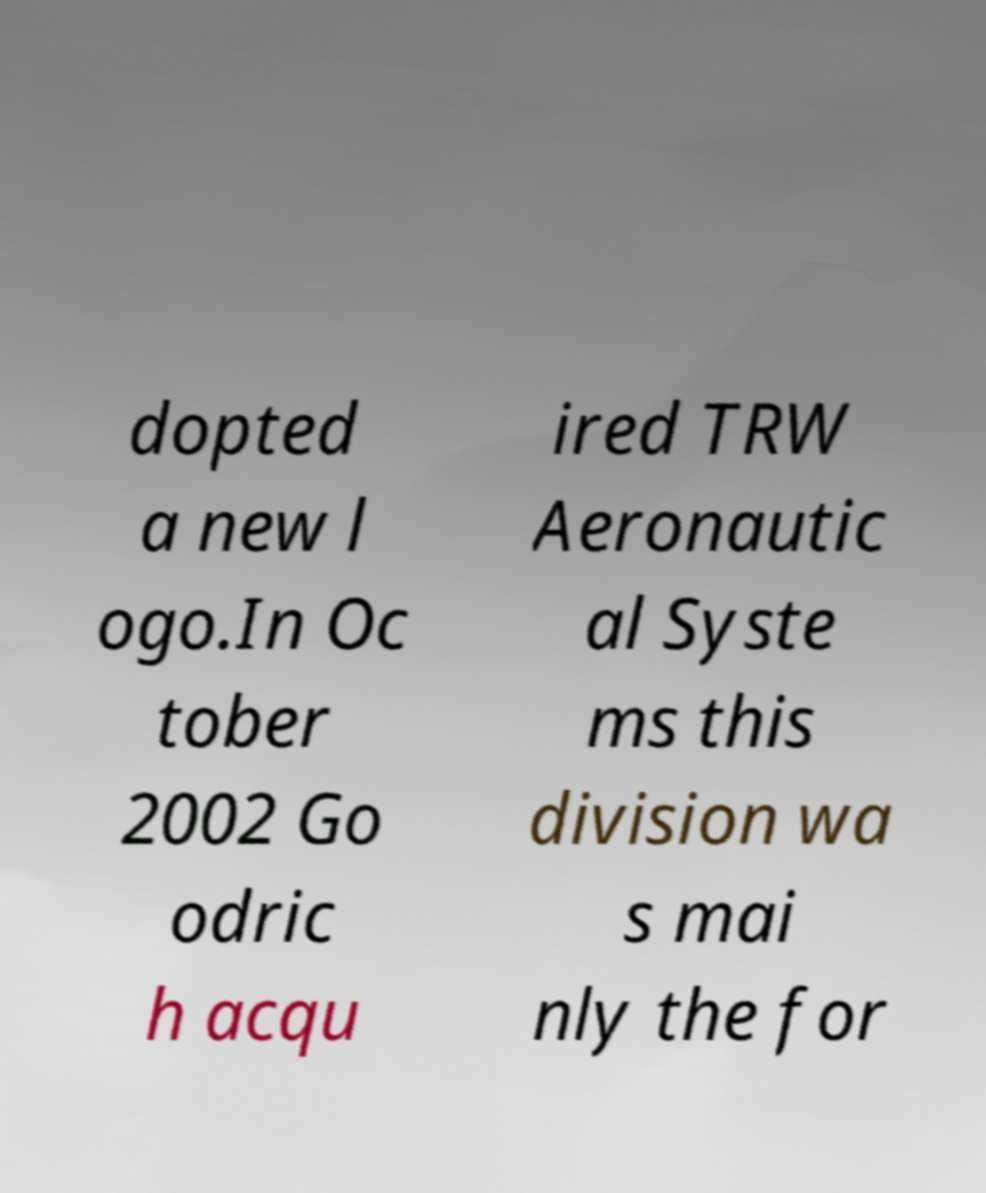Could you extract and type out the text from this image? dopted a new l ogo.In Oc tober 2002 Go odric h acqu ired TRW Aeronautic al Syste ms this division wa s mai nly the for 